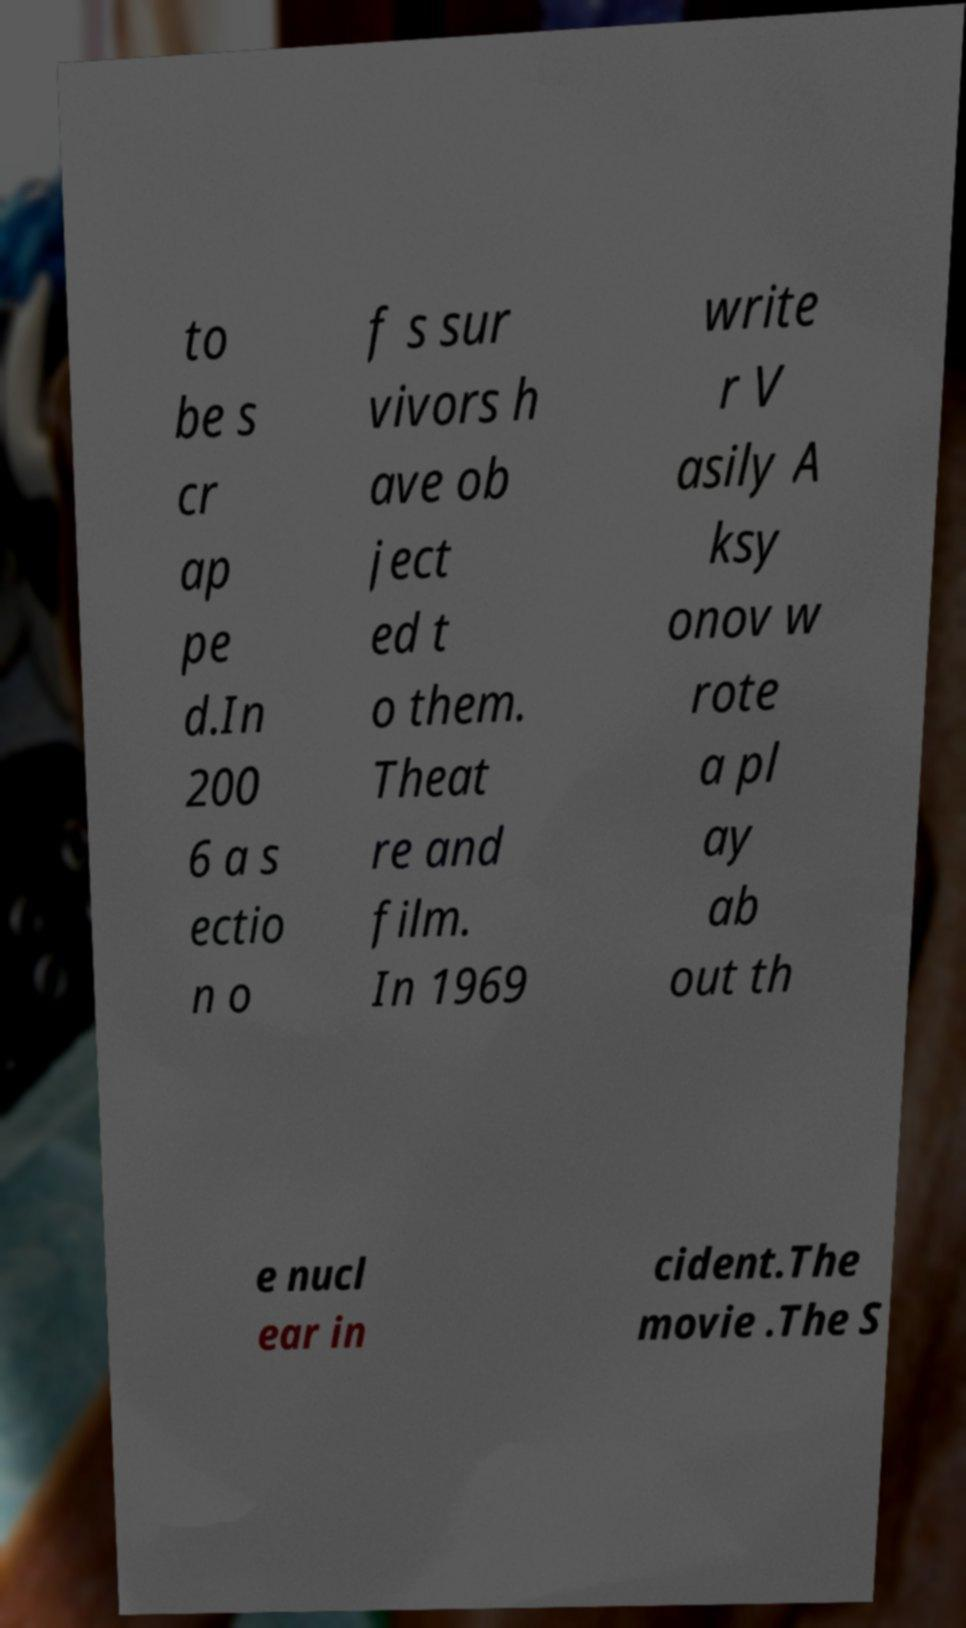What messages or text are displayed in this image? I need them in a readable, typed format. to be s cr ap pe d.In 200 6 a s ectio n o f s sur vivors h ave ob ject ed t o them. Theat re and film. In 1969 write r V asily A ksy onov w rote a pl ay ab out th e nucl ear in cident.The movie .The S 